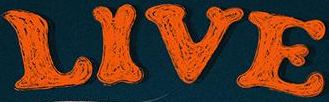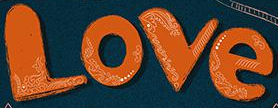Read the text from these images in sequence, separated by a semicolon. LIVE; Love 